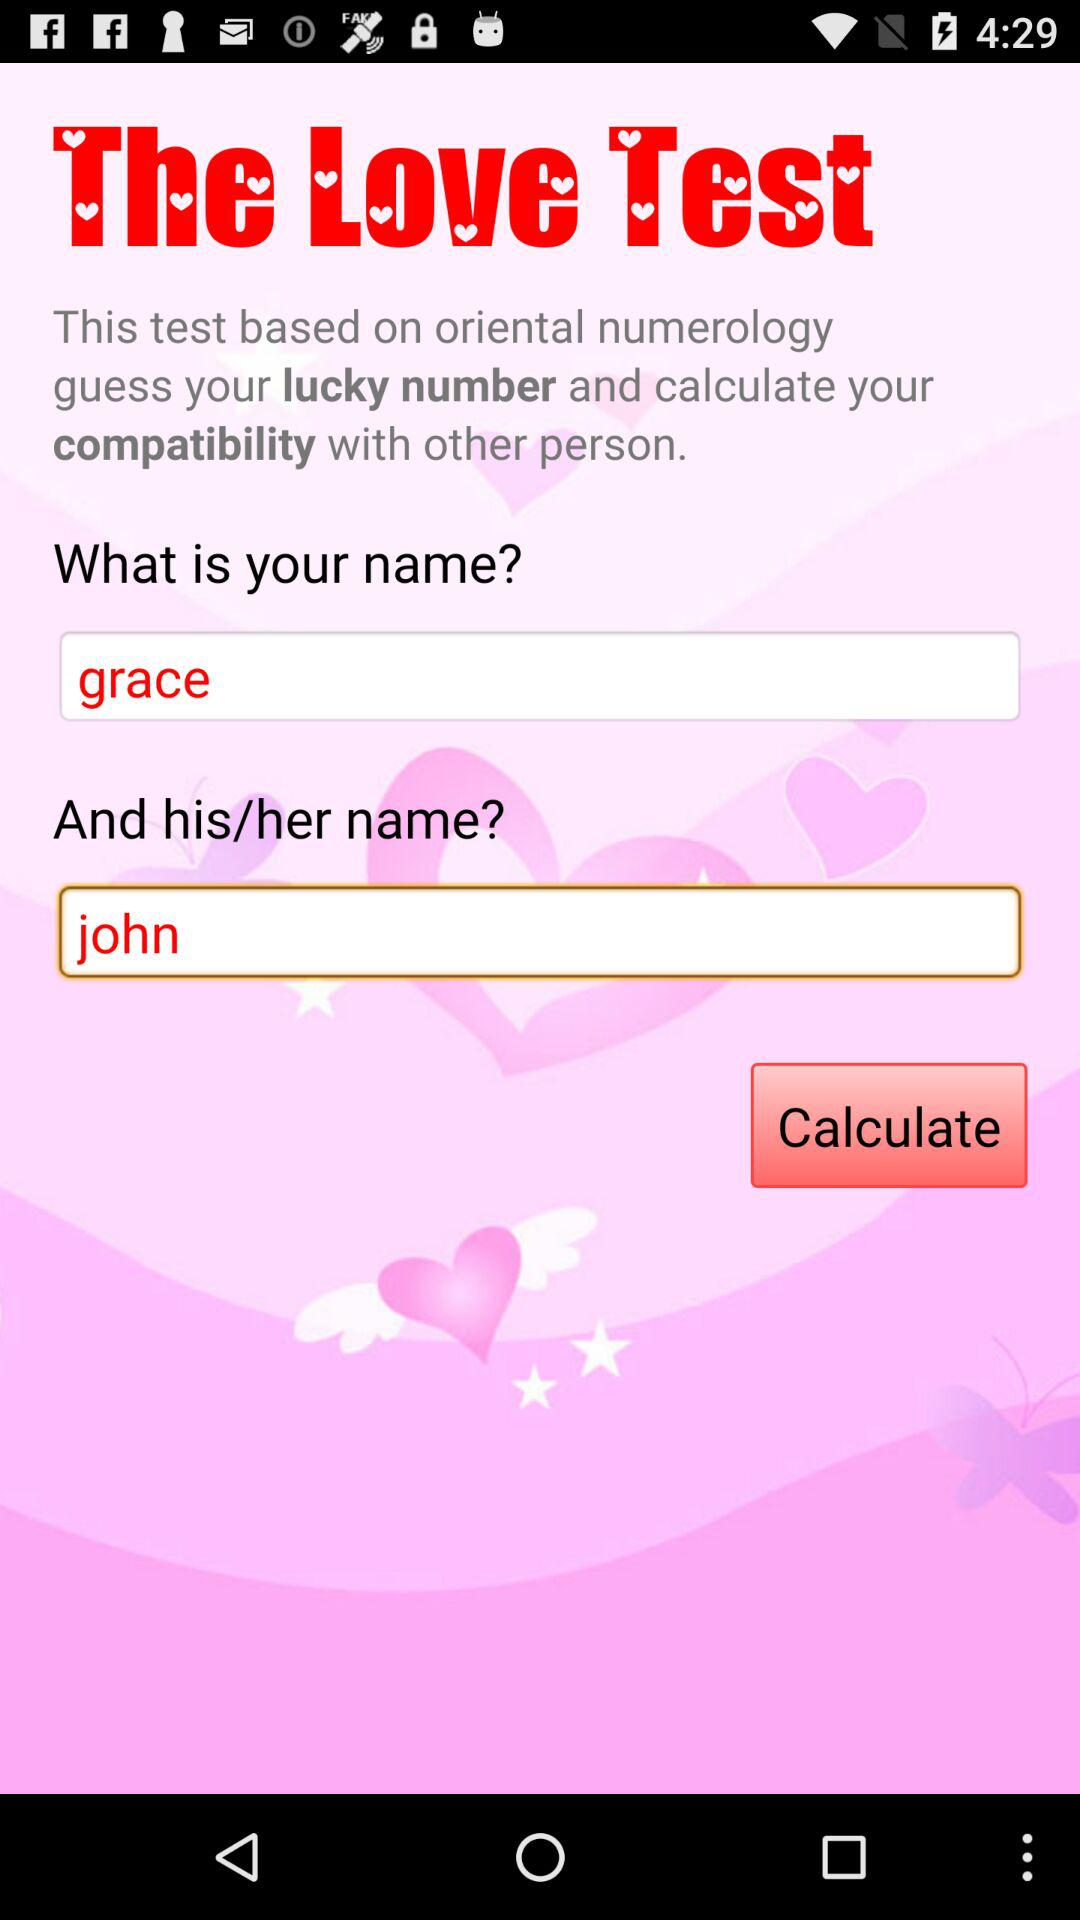What is the name of the user? The user name is Grace. 